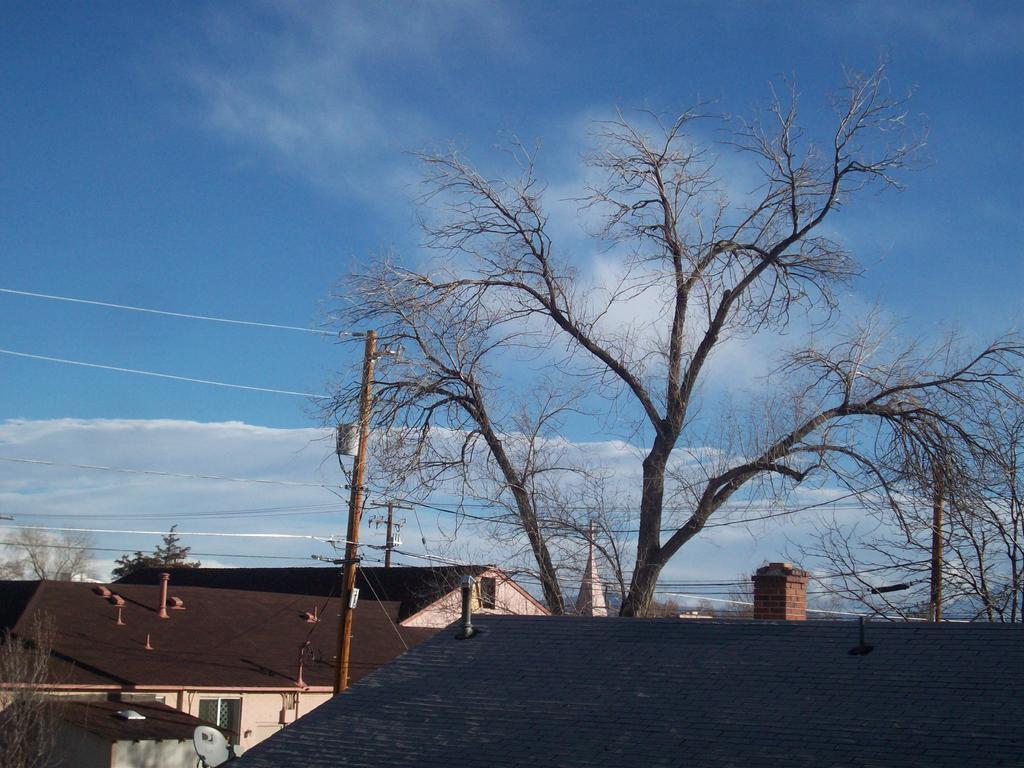What type of structures are located at the bottom side of the image? There are houses at the bottom side of the image. What can be seen in the center of the image? There is a tree in the center of the image. What type of oven can be seen in the image? There is no oven present in the image. How many spiders are crawling on the tree in the image? There are no spiders visible in the image; it only features a tree. 